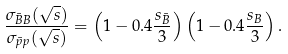Convert formula to latex. <formula><loc_0><loc_0><loc_500><loc_500>\frac { \sigma _ { \bar { B } B } ( \sqrt { s } ) } { \sigma _ { \bar { p } p } ( \sqrt { s } ) } = \left ( 1 - 0 . 4 \frac { s _ { \bar { B } } } { 3 } \right ) \left ( 1 - 0 . 4 \frac { s _ { B } } { 3 } \right ) .</formula> 